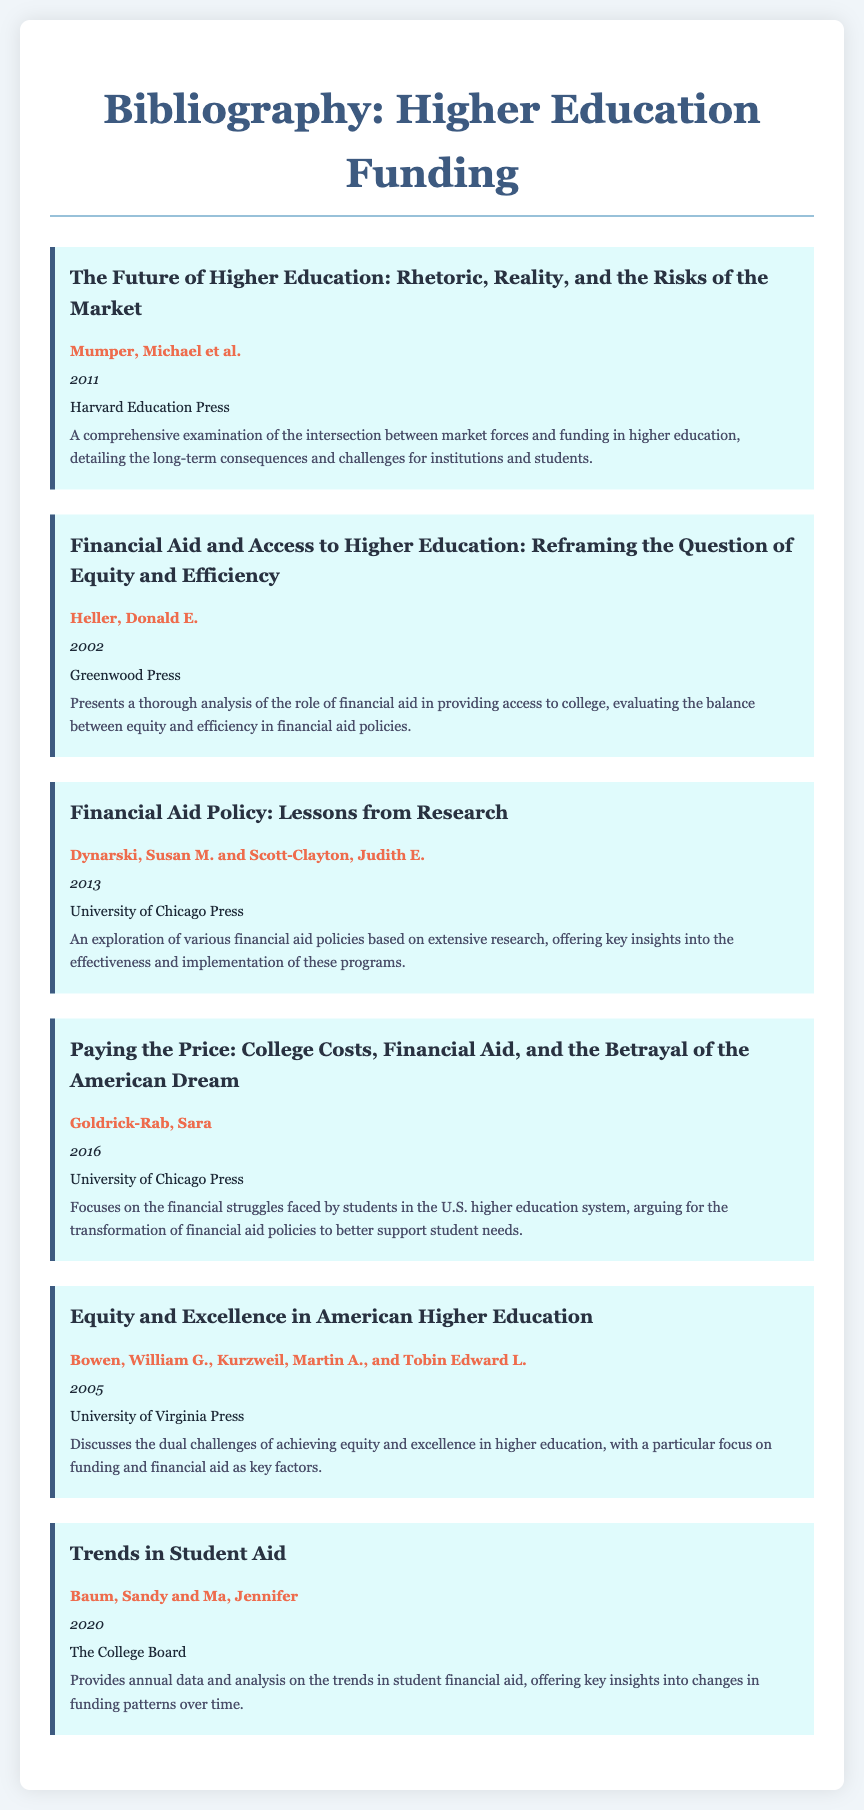what is the title of the first item? The title of the first item is the first title listed in the bibliography section.
Answer: The Future of Higher Education: Rhetoric, Reality, and the Risks of the Market who are the authors of the third item? The authors of the third item are mentioned directly under the title in the bibliography.
Answer: Dynarski, Susan M. and Scott-Clayton, Judith E what year was "Paying the Price" published? The year is indicated next to the title and author in the document.
Answer: 2016 how many items are listed in the bibliography? The total number of items can be counted from the list provided in the document.
Answer: 6 which publisher is associated with the item authored by Heller? The publisher is mentioned below the author's name and year for that specific item.
Answer: Greenwood Press what is the focus of the item titled "Trends in Student Aid"? The focus is described in the summary following the title and authors in the document.
Answer: Annual data and analysis on the trends in student financial aid which item discusses the challenges of achieving equity and excellence? This is a description of one of the items in the bibliography section.
Answer: Equity and Excellence in American Higher Education 